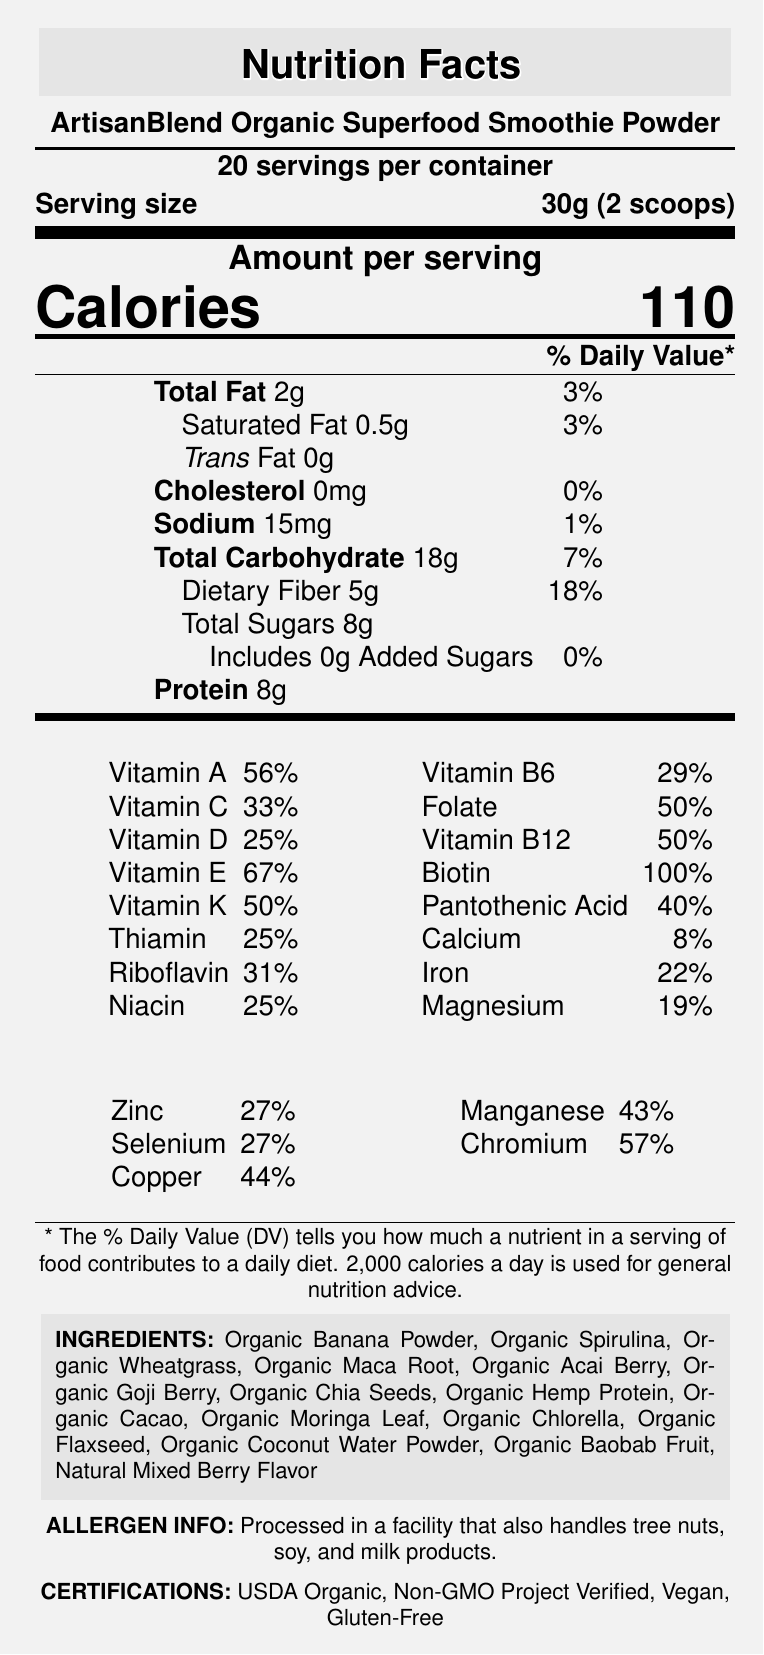what is the serving size? The serving size is specified towards the top of the document under "Serving size".
Answer: 30g (2 scoops) How many calories are in one serving? The calorie content per serving is listed as "Calories 110" in the "Amount per serving" section.
Answer: 110 calories What percentage of the daily value of Vitamin A is provided per serving? The document lists the daily value percentages in a two-column format, and Vitamin A is shown to provide 56% of the daily value per serving.
Answer: 56% How much dietary fiber does one serving contain? The dietary fiber content per serving is listed as "Dietary Fiber 5g" in the nutrient rows of the "Amount per serving" section.
Answer: 5g What are the first three ingredients listed? The ingredients are listed towards the bottom of the document, where the first three ingredients are Organic Banana Powder, Organic Spirulina, and Organic Wheatgrass.
Answer: Organic Banana Powder, Organic Spirulina, Organic Wheatgrass Which vitamin has the highest daily value percentage in this product? The document lists Biotin as having 100% of the daily value, which is the highest percentage among all listed vitamins and minerals.
Answer: Biotin Does this product contain any added sugars? The document states "Includes 0g Added Sugars" in the nutrient rows of the "Amount per serving" section, indicating there are no added sugars.
Answer: No Which of the following certifications does this product have? A. USDA Organic B. Non-GMO Project Verified C. Vegan D. All of the above The document lists certifications towards the bottom, indicating the product is USDA Organic, Non-GMO Project Verified, Vegan, and Gluten-Free.
Answer: D. All of the above What is the percentage of daily value for Iron? A. 19% B. 22% C. 25% D. 28% Iron is shown to have 22% of the daily value in the document.
Answer: B Is this product gluten-free? The document specifically lists "Gluten-Free" under certifications.
Answer: Yes Summarize the main nutritional elements highlighted in this document. The document provides a detailed nutritional profile, highlighting essential vitamins and minerals, ingredients, certifications, and the product’s compliance with certain dietary restrictions.
Answer: The ArtisanBlend Organic Superfood Smoothie Powder provides 110 calories per 30g serving, with significant contributions to daily values of various vitamins and minerals. It contains no cholesterol, minimal sodium, and offers high amounts of dietary fiber (5g) and protein (8g). Vitamins A, C, D, E, K, and several B vitamins, as well as biotin, folate, and minerals like iron, calcium, magnesium, and zinc, are well represented. The product is organic, vegan, non-GMO, and gluten-free, with a wide range of superfood ingredients. What percentage of the daily value of protein is provided per serving? The document lists the protein content as 8g but does not specify the percentage of the daily value.
Answer: Not enough information What is the allergen information provided about this product? The allergen information states that the product is processed in a facility that also handles tree nuts, soy, and milk products.
Answer: Processed in a facility that also handles tree nuts, soy, and milk products. 